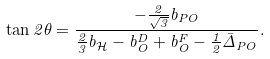<formula> <loc_0><loc_0><loc_500><loc_500>\tan { 2 \theta } = \frac { - \frac { 2 } { \sqrt { 3 } } b _ { P O } } { \frac { 2 } { 3 } b _ { \mathcal { H } } - b _ { O } ^ { D } + b _ { O } ^ { F } - \frac { 1 } { 2 } \bar { \Delta } _ { P O } } .</formula> 